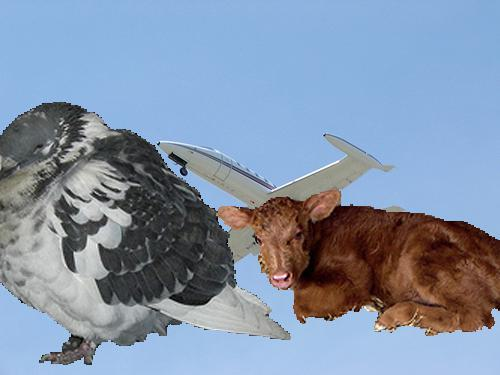What might the calf signify in this image? The presence of the calf, looking somewhat out of place next to the fantastical bird-aeroplane, could represent innocence, nature, or a grounded reality in contrast to the flight of fancy depicted by the bird. 